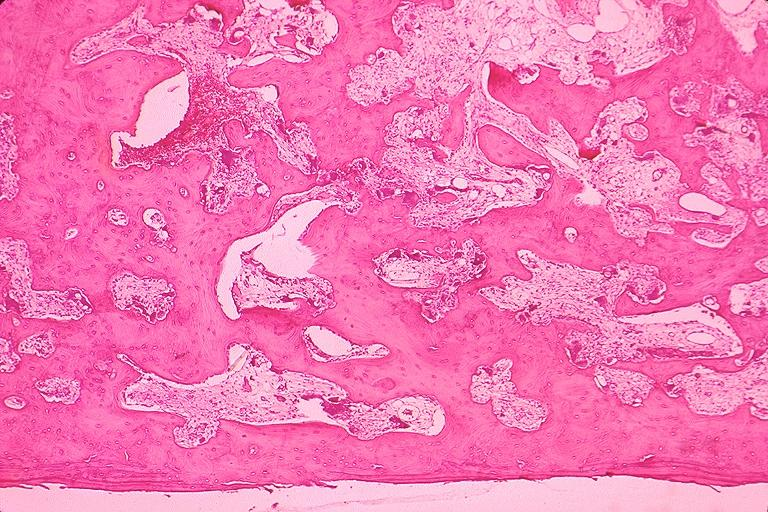s oral present?
Answer the question using a single word or phrase. Yes 